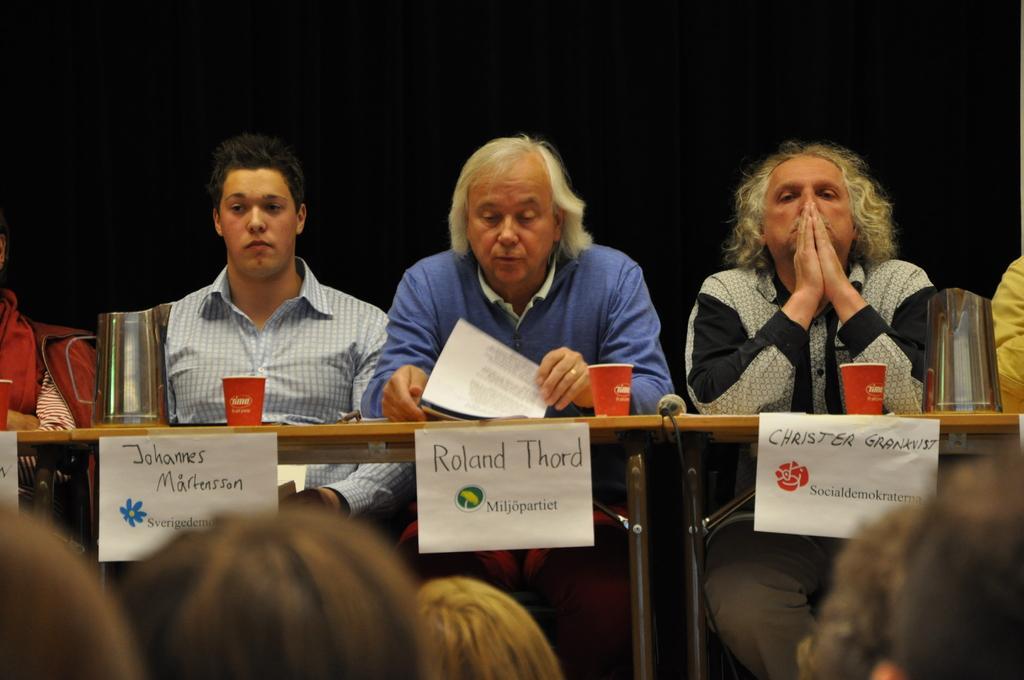In one or two sentences, can you explain what this image depicts? In the center of the image there are people sitting on chairs. There is a table on which there are objects. At the bottom of the image there are people. In the background of the image there is a black color cloth. 